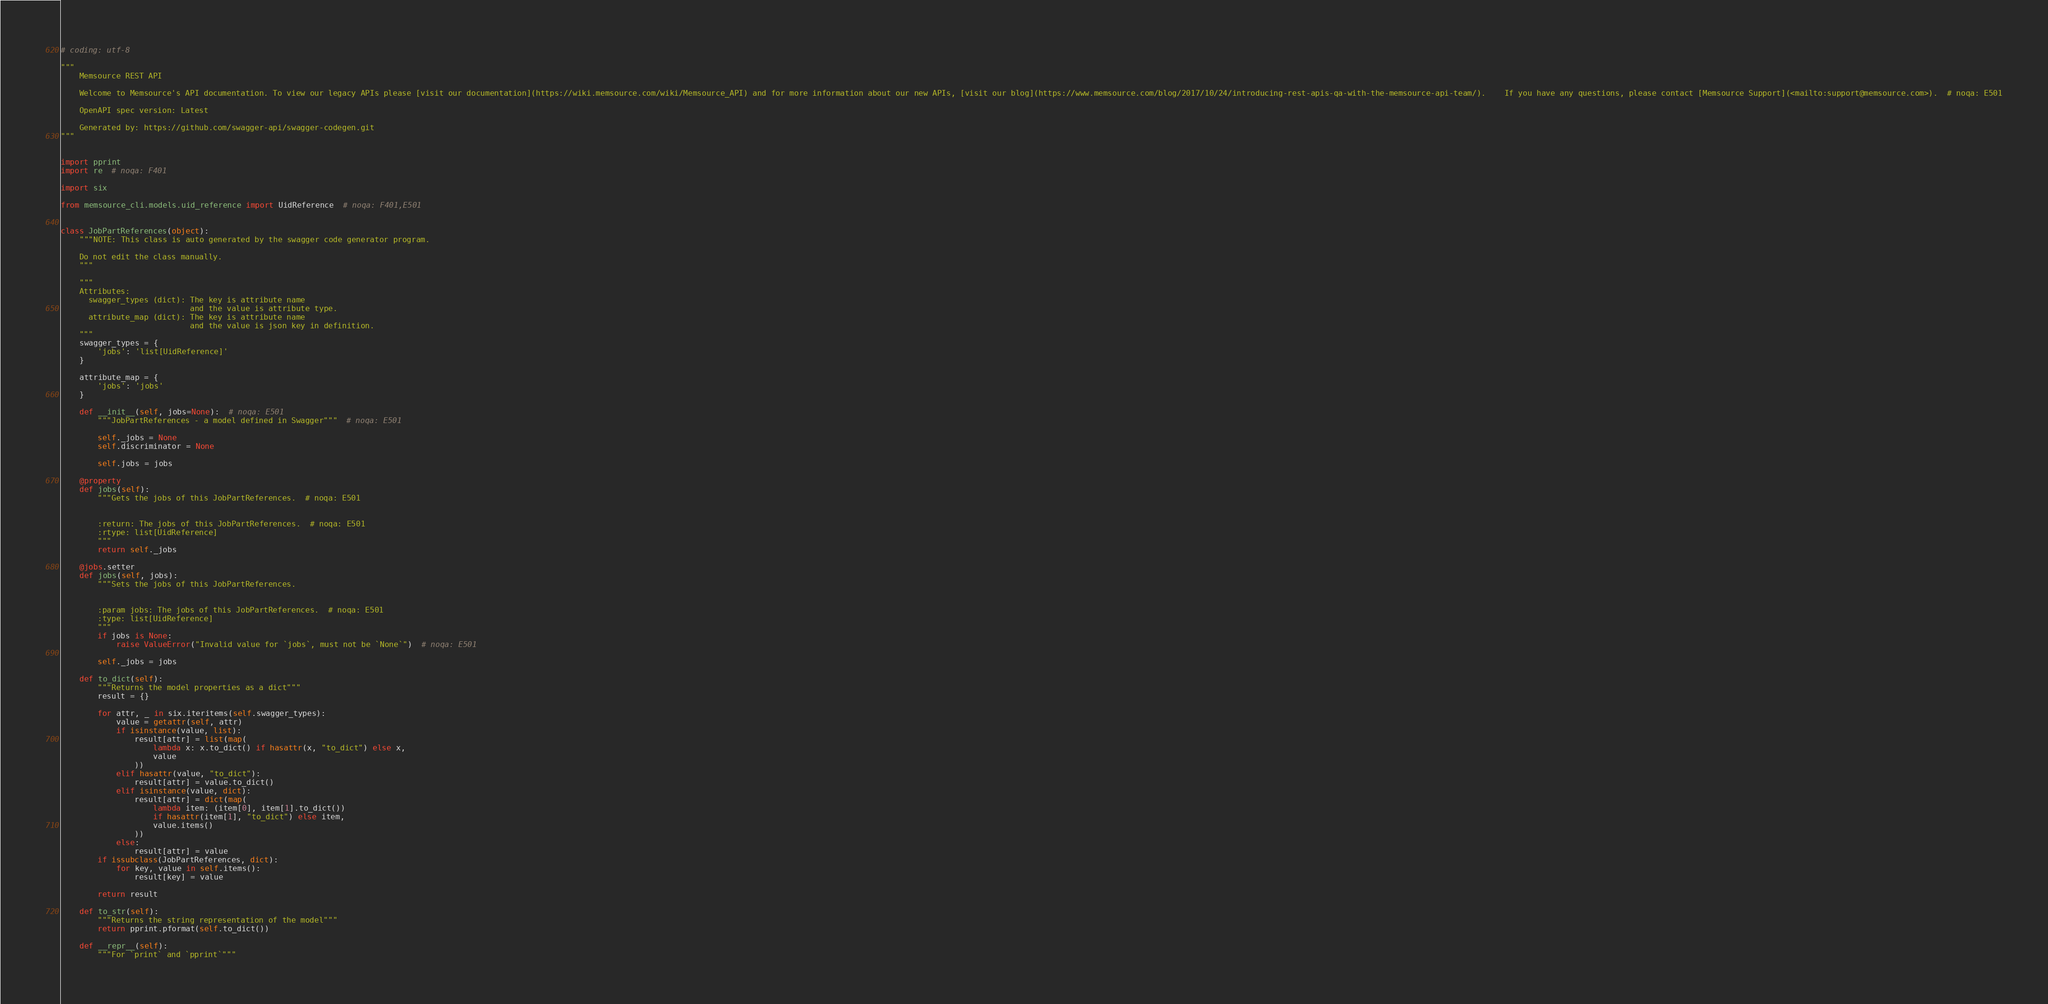Convert code to text. <code><loc_0><loc_0><loc_500><loc_500><_Python_># coding: utf-8

"""
    Memsource REST API

    Welcome to Memsource's API documentation. To view our legacy APIs please [visit our documentation](https://wiki.memsource.com/wiki/Memsource_API) and for more information about our new APIs, [visit our blog](https://www.memsource.com/blog/2017/10/24/introducing-rest-apis-qa-with-the-memsource-api-team/).    If you have any questions, please contact [Memsource Support](<mailto:support@memsource.com>).  # noqa: E501

    OpenAPI spec version: Latest
    
    Generated by: https://github.com/swagger-api/swagger-codegen.git
"""


import pprint
import re  # noqa: F401

import six

from memsource_cli.models.uid_reference import UidReference  # noqa: F401,E501


class JobPartReferences(object):
    """NOTE: This class is auto generated by the swagger code generator program.

    Do not edit the class manually.
    """

    """
    Attributes:
      swagger_types (dict): The key is attribute name
                            and the value is attribute type.
      attribute_map (dict): The key is attribute name
                            and the value is json key in definition.
    """
    swagger_types = {
        'jobs': 'list[UidReference]'
    }

    attribute_map = {
        'jobs': 'jobs'
    }

    def __init__(self, jobs=None):  # noqa: E501
        """JobPartReferences - a model defined in Swagger"""  # noqa: E501

        self._jobs = None
        self.discriminator = None

        self.jobs = jobs

    @property
    def jobs(self):
        """Gets the jobs of this JobPartReferences.  # noqa: E501


        :return: The jobs of this JobPartReferences.  # noqa: E501
        :rtype: list[UidReference]
        """
        return self._jobs

    @jobs.setter
    def jobs(self, jobs):
        """Sets the jobs of this JobPartReferences.


        :param jobs: The jobs of this JobPartReferences.  # noqa: E501
        :type: list[UidReference]
        """
        if jobs is None:
            raise ValueError("Invalid value for `jobs`, must not be `None`")  # noqa: E501

        self._jobs = jobs

    def to_dict(self):
        """Returns the model properties as a dict"""
        result = {}

        for attr, _ in six.iteritems(self.swagger_types):
            value = getattr(self, attr)
            if isinstance(value, list):
                result[attr] = list(map(
                    lambda x: x.to_dict() if hasattr(x, "to_dict") else x,
                    value
                ))
            elif hasattr(value, "to_dict"):
                result[attr] = value.to_dict()
            elif isinstance(value, dict):
                result[attr] = dict(map(
                    lambda item: (item[0], item[1].to_dict())
                    if hasattr(item[1], "to_dict") else item,
                    value.items()
                ))
            else:
                result[attr] = value
        if issubclass(JobPartReferences, dict):
            for key, value in self.items():
                result[key] = value

        return result

    def to_str(self):
        """Returns the string representation of the model"""
        return pprint.pformat(self.to_dict())

    def __repr__(self):
        """For `print` and `pprint`"""</code> 